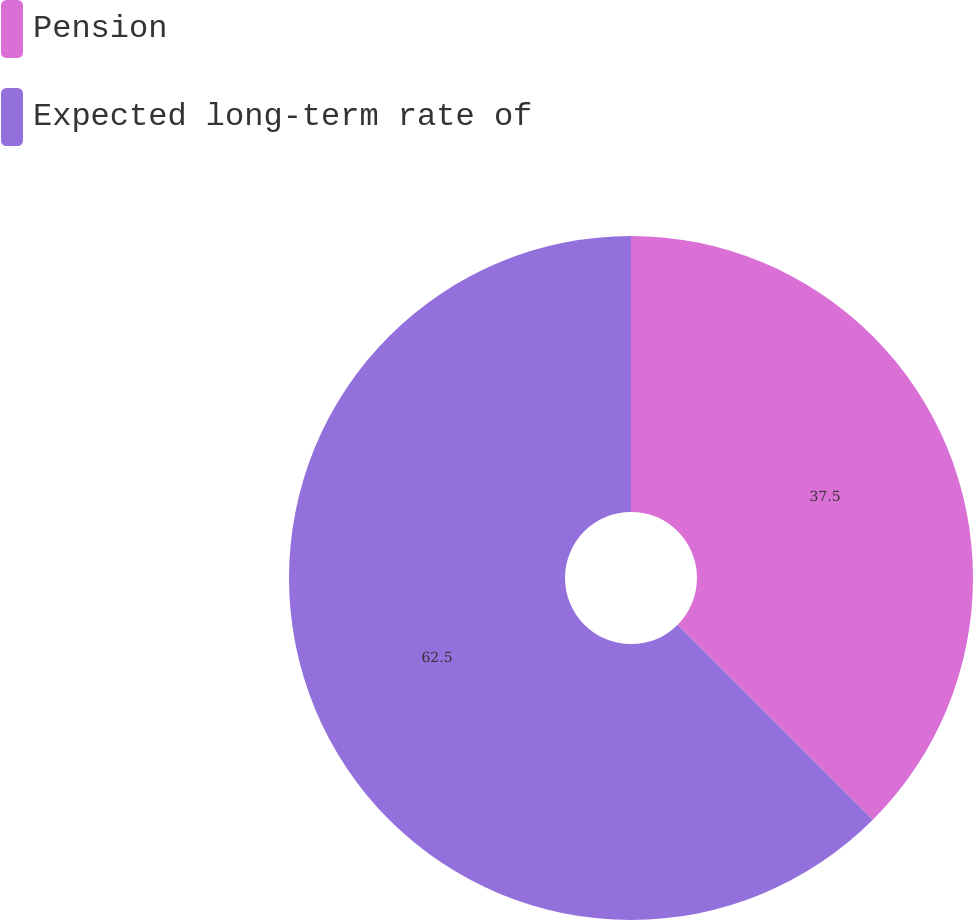<chart> <loc_0><loc_0><loc_500><loc_500><pie_chart><fcel>Pension<fcel>Expected long-term rate of<nl><fcel>37.5%<fcel>62.5%<nl></chart> 